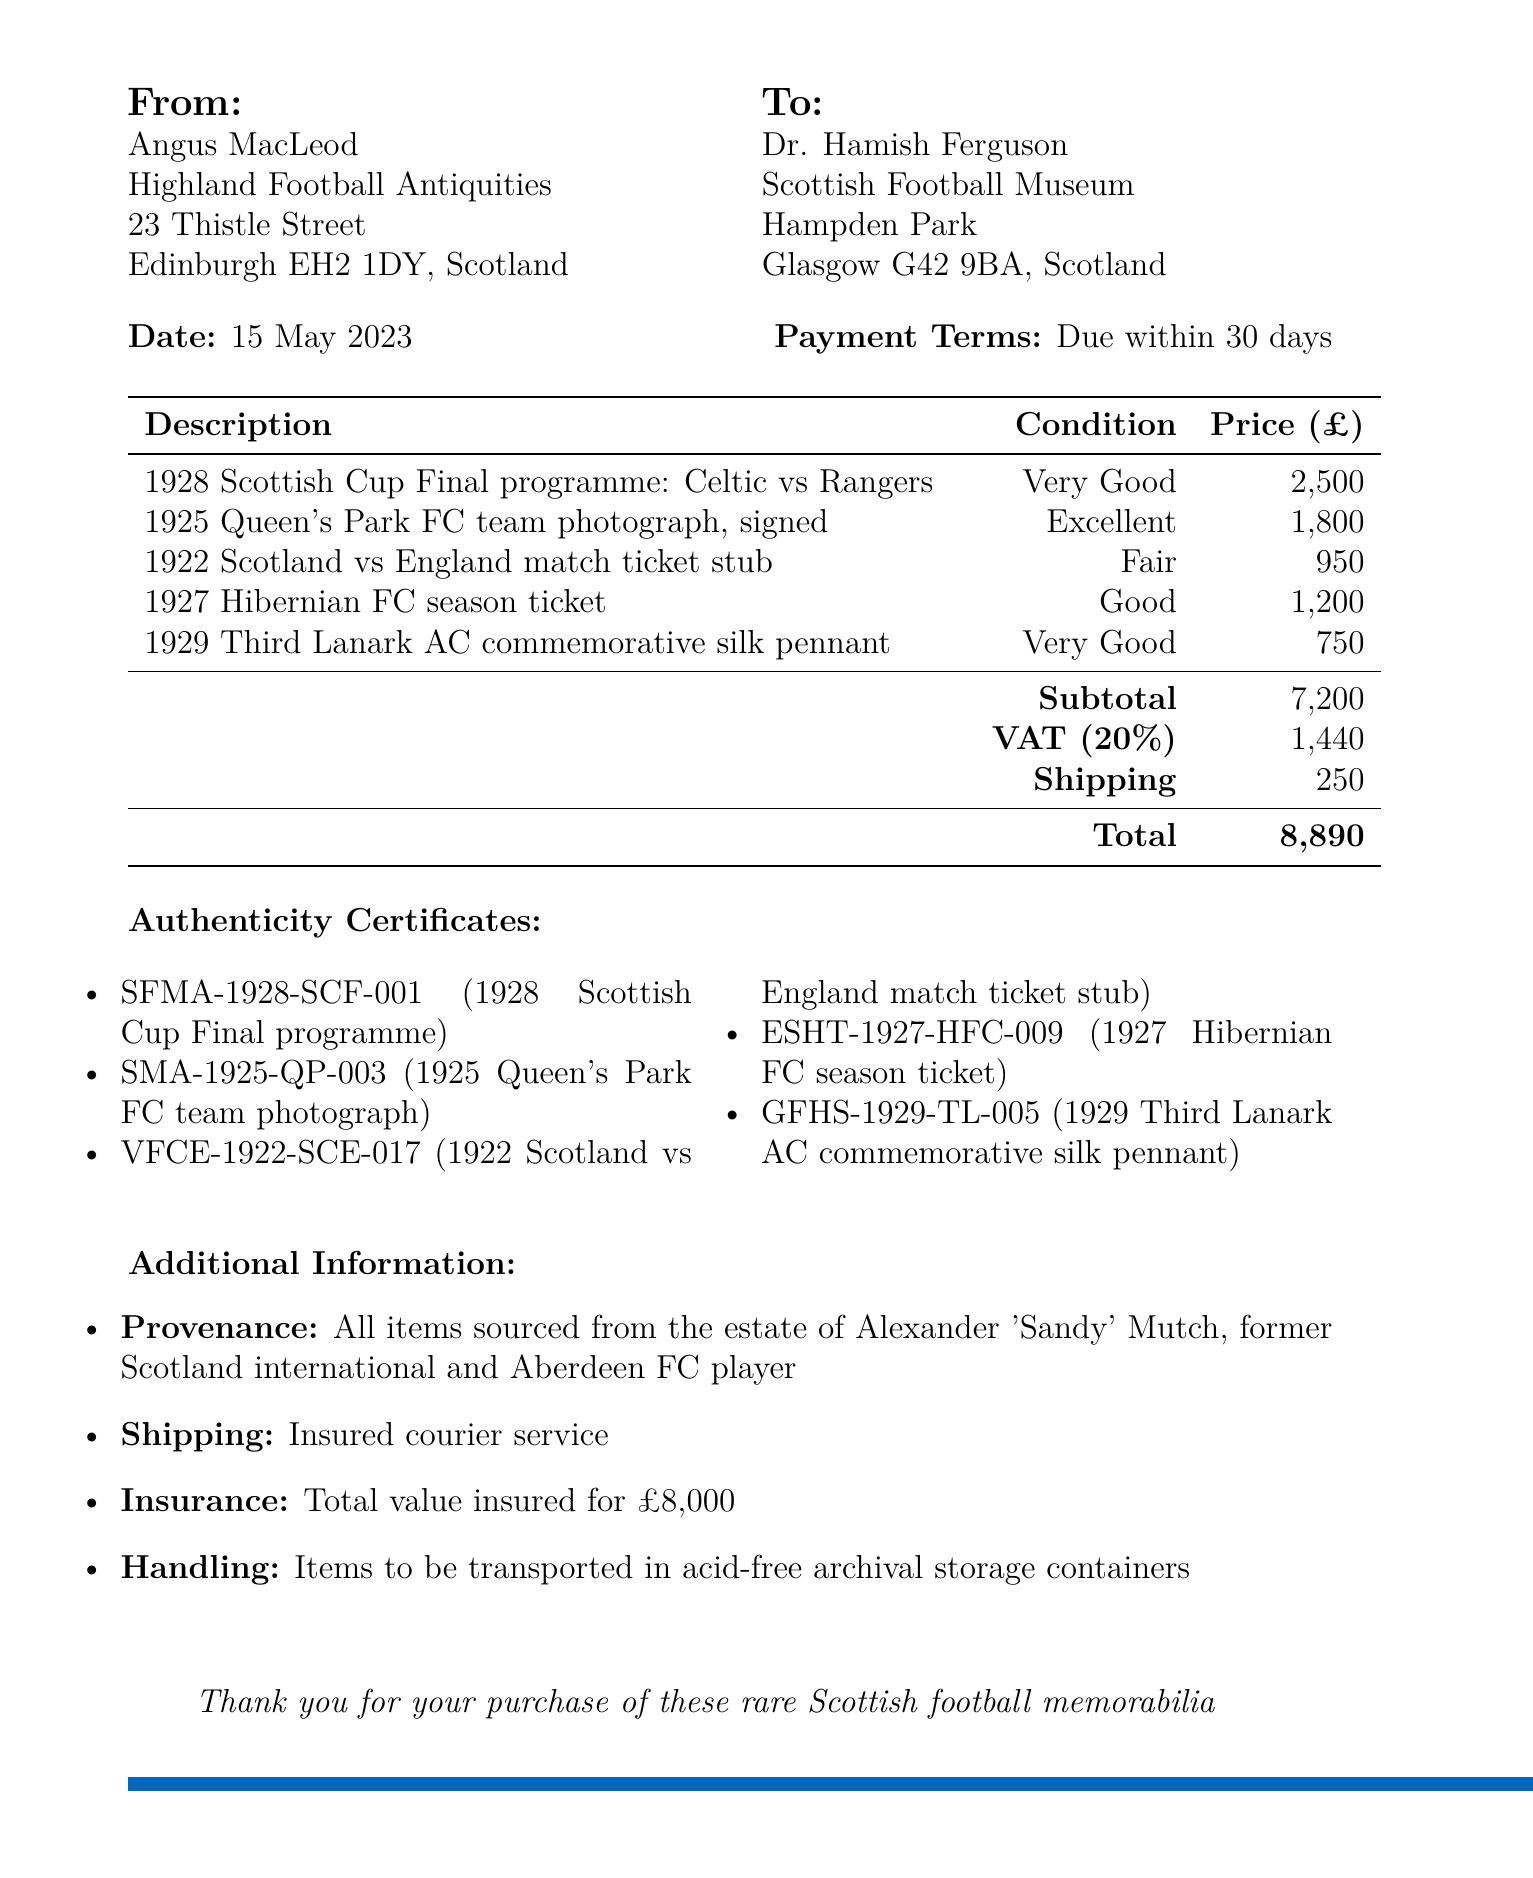What is the invoice number? The invoice number is listed directly in the document and is uniquely assigned to this transaction.
Answer: HFA-2023-0142 Who is the seller of the items? The seller's name and company are provided at the top of the document, identifying who sold the memorabilia.
Answer: Angus MacLeod, Highland Football Antiquities What is the total amount due? The total amount is calculated as the sum of the subtotal, VAT, and shipping costs listed in the document.
Answer: 8890 What is the provenance of the items? The provenance section details the sourcing of the items, reflecting their historical significance.
Answer: All items sourced from the estate of Alexander 'Sandy' Mutch What authenticity certificate number corresponds to the 1925 Queen's Park FC team photograph? The document itemizes each item along with its corresponding certificate number for authenticity verification.
Answer: SMA-1925-QP-003 How many items are listed in the invoice? The count of the items is derived from the itemized list included in the document.
Answer: 5 What is the shipping method stated in the document? The shipping details provide insight into how the items will be delivered, ensuring their safety during transit.
Answer: Insured courier service What condition is the 1922 Scotland vs England match ticket stub listed as? The condition of each item is provided, which is essential for collectors assessing the item's quality.
Answer: Fair What is the VAT rate applied in the invoice? The document specifies the VAT amount, which is based on a percentage of the subtotal, giving insight into applicable taxes.
Answer: 20% 